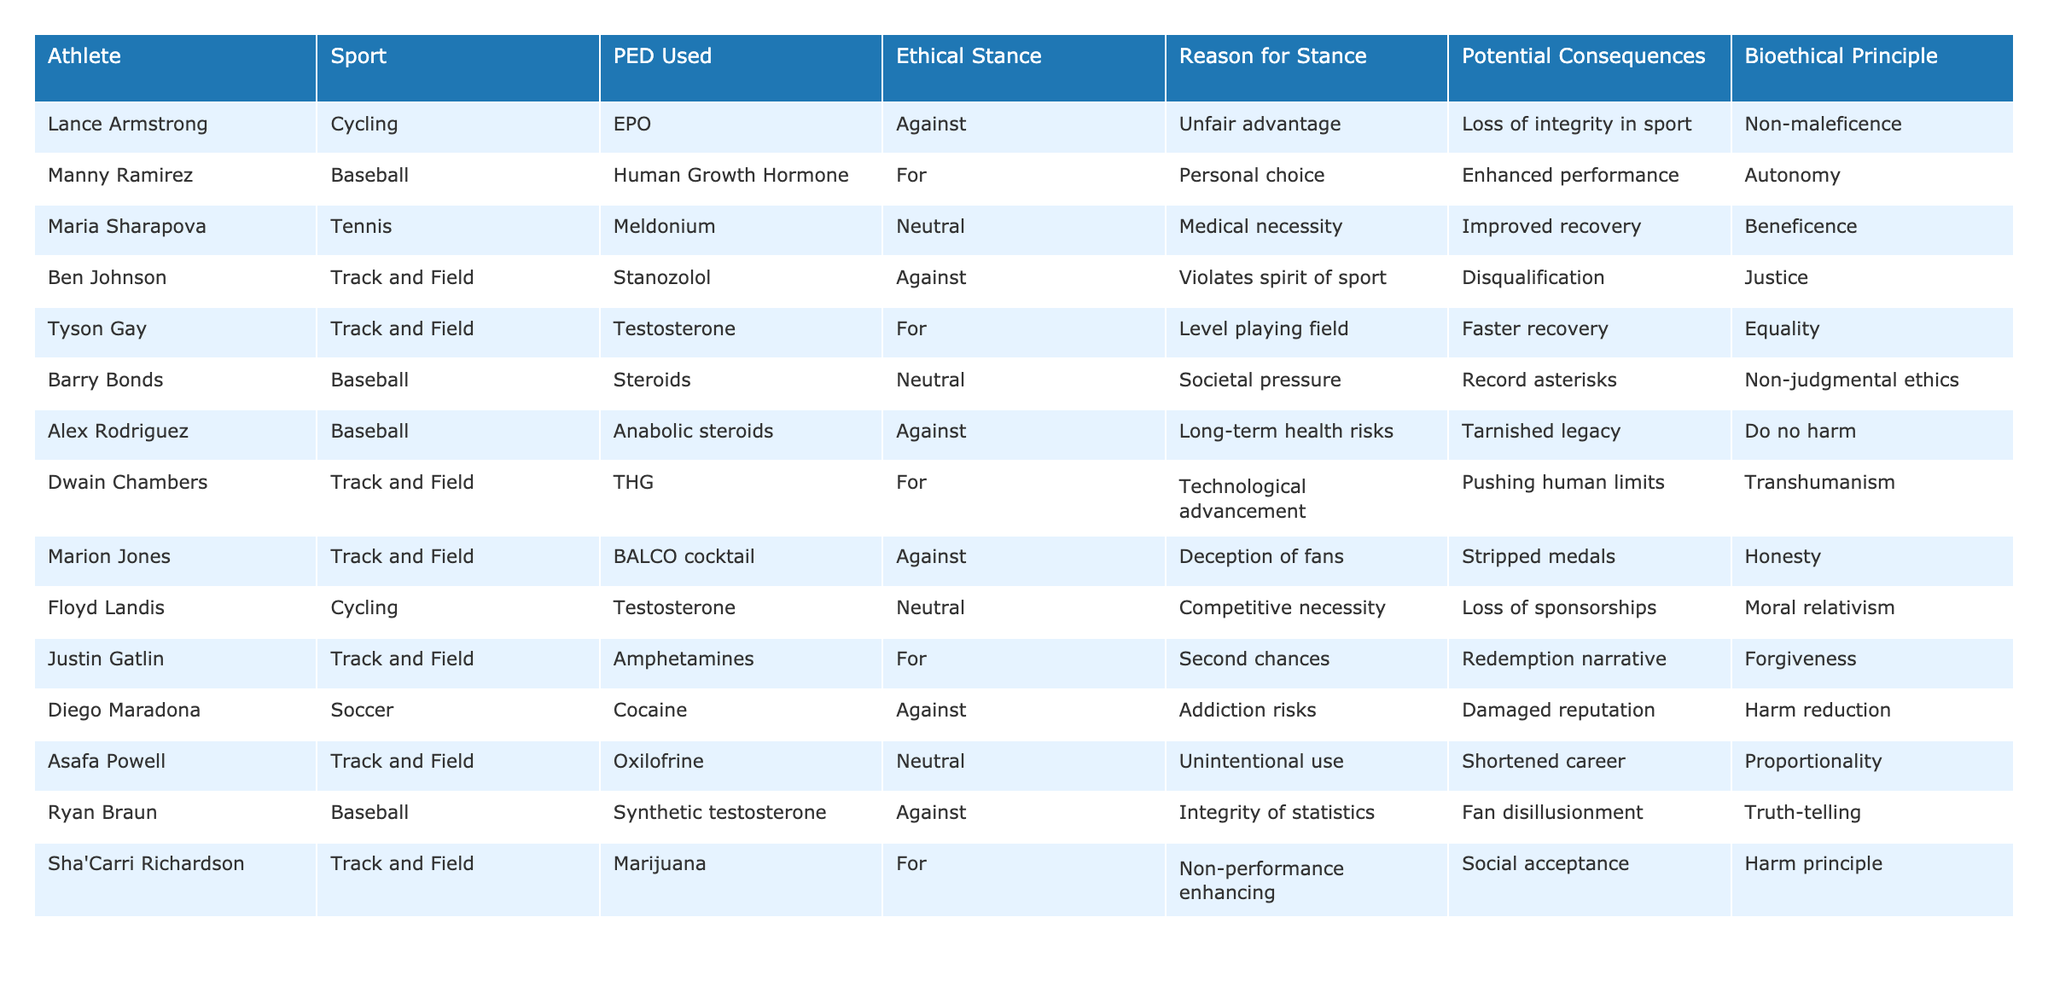What performance-enhancing drug did Lance Armstrong use? The table clearly lists Lance Armstrong under the athlete column and shows the corresponding PED used, which is EPO.
Answer: EPO How many athletes have a neutral ethical stance? By counting the entries in the ethical stance column, there are three athletes with a neutral stance: Maria Sharapova, Barry Bonds, and Floyd Landis.
Answer: 3 Did Tyson Gay use a performance-enhancing drug? The table indicates that Tyson Gay used testosterone, which qualifies as a performance-enhancing drug.
Answer: Yes Which athlete is associated with the ethical principle of equality? By looking at the table, Tyson Gay is the athlete associated with the ethical principle of equality.
Answer: Tyson Gay List the bioethical principles associated with athletes using performance-enhancing drugs. The table shows various bioethical principles including non-maleficence, autonomy, beneficence, justice, equality, transhumanism, harm reduction, proportionality, truth-telling, and forgiveness.
Answer: Multiple principles Who is the athlete that believes in the potential of technological advancement? According to the table, Dwain Chambers believes in technological advancement and uses THG.
Answer: Dwain Chambers What are the potential consequences mentioned for using meldonium? The table indicates that the potential consequence of using meldonium is improved recovery, as stated by Maria Sharapova.
Answer: Improved recovery How many athletes are against the use of performance-enhancing drugs? There are five athletes who are against the use of PEDs: Lance Armstrong, Ben Johnson, Alex Rodriguez, Marion Jones, and Ryan Braun, making a total of five.
Answer: 5 Which athlete faces reputation risks due to addiction? The table reveals that Diego Maradona faces reputation risks due to addiction from using cocaine.
Answer: Diego Maradona What is the main reason for Sha'Carri Richardson's stance on performance-enhancing drugs? The table shows that Sha'Carri Richardson's stance is based on the argument that marijuana is non-performance enhancing and socially accepted.
Answer: Non-performance enhancing Which athlete's actions led to a loss of integrity in sport? The explanation for Lance Armstrong's stance indicates that his actions led to a loss of integrity in sport.
Answer: Lance Armstrong Why might some athletes feel societal pressure regarding performance-enhancing drugs? The table shows Barry Bonds as neutral due to societal pressure, which suggests that societal expectations may lead athletes to consider performance enhancement.
Answer: Societal pressure What ethical principle is associated with Justin Gatlin's stance? Justin Gatlin's ethical stance aligns with forgiveness, as indicated in the bioethical principle column.
Answer: Forgiveness Is there any athlete who used performance-enhancing drugs despite their medical necessity? The table shows Maria Sharapova's use of meldonium under a neutral stance, suggesting a medical necessity angle.
Answer: Yes How do the reasons for stance on PEDs compare between athletes in baseball and track and field? In reviewing the table, baseball athletes cite personal choice and societal pressure, whereas track and field athletes mention competition necessity and redemption, indicating differing motivations.
Answer: Differing motivations 